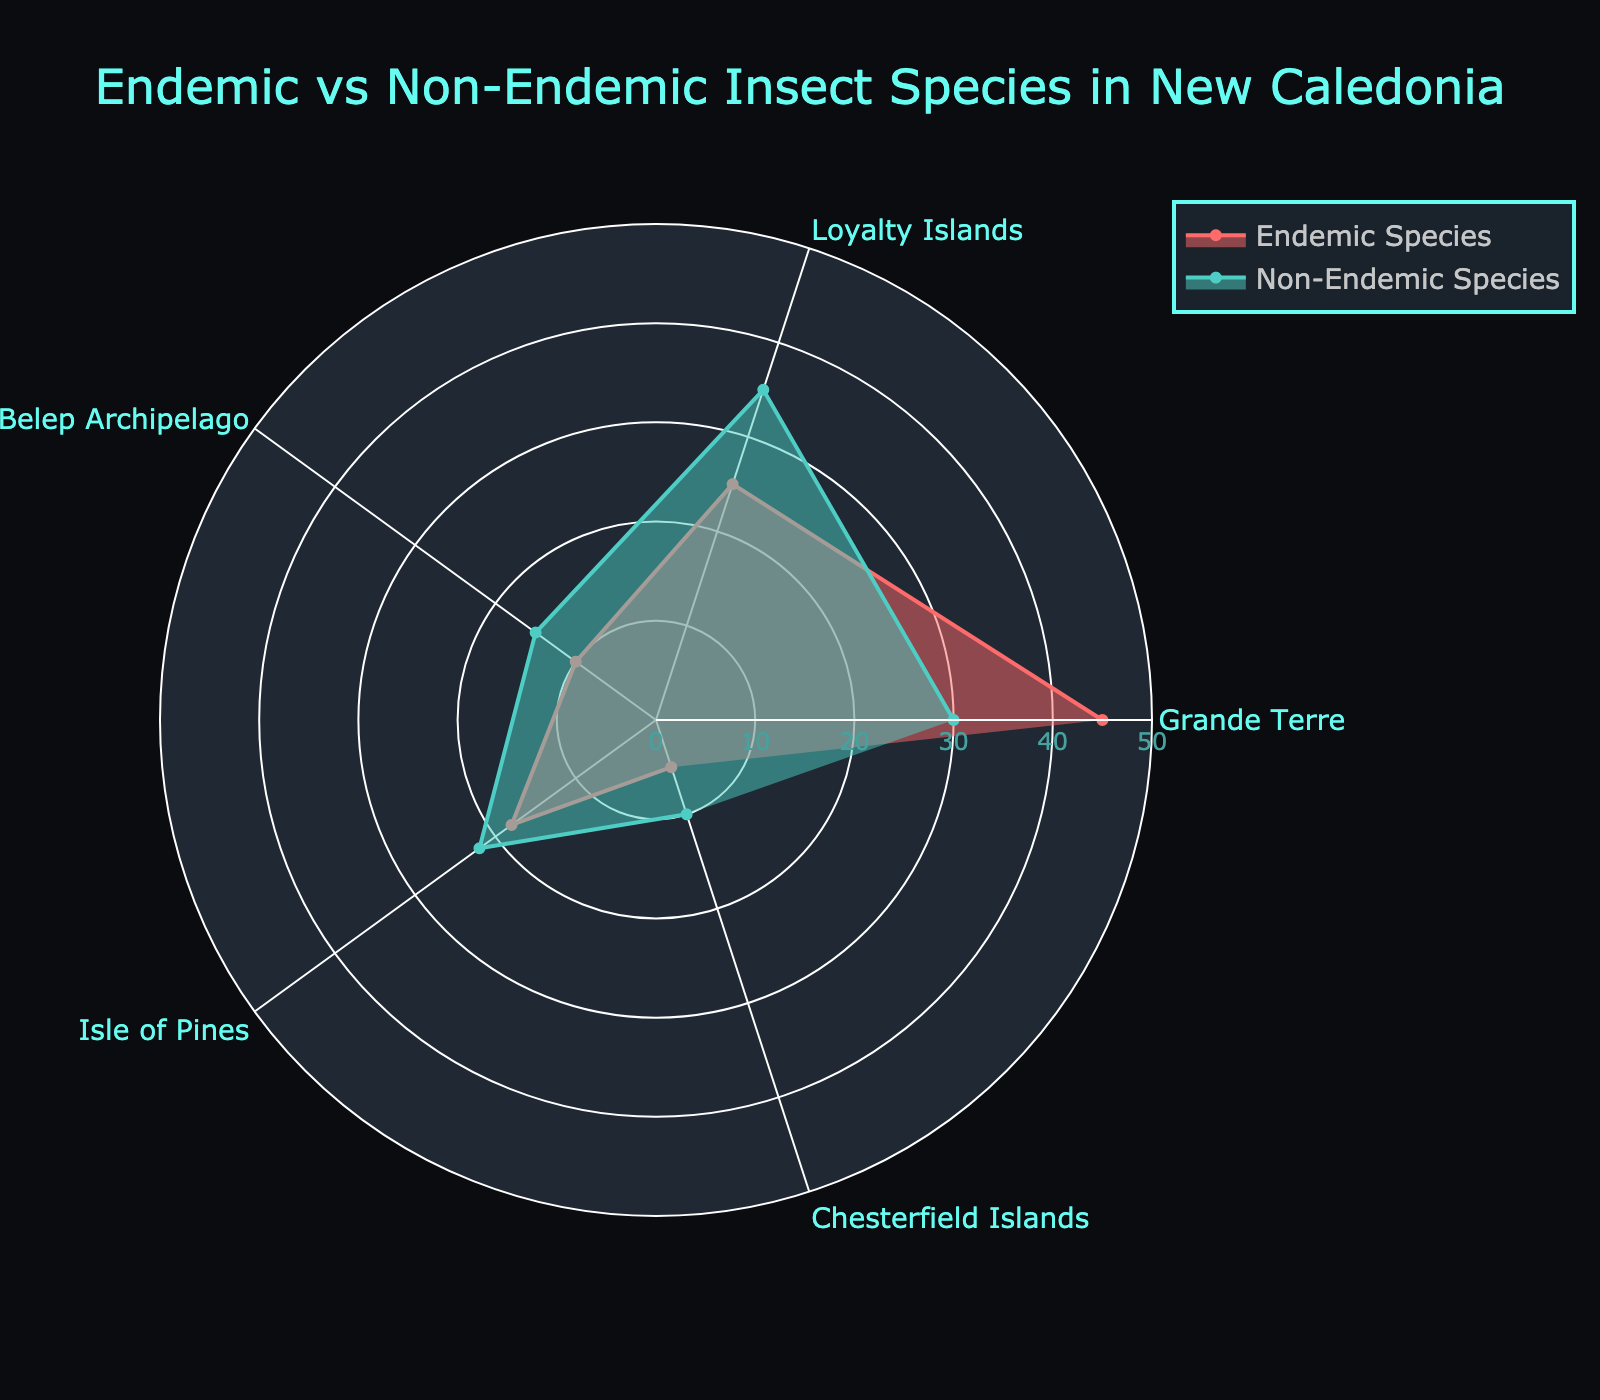What's the title of the radar chart? The title is typically displayed prominently at the top of the radar chart to give context about the data visualized.
Answer: Endemic vs Non-Endemic Insect Species in New Caledonia Which region has the highest number of endemic species? By visually inspecting the plot, we can see which region has the furthest point from the center for the endemic series.
Answer: Grande Terre In which region is the difference between endemic and non-endemic species smallest? We observe the radar chart and look for the regions where the points for endemic and non-endemic species are closest together.
Answer: Belep Archipelago What's the total number of endemic species across all regions? Sum of the endemic species across Grande Terre, Loyalty Islands, Belep Archipelago, Isle of Pines, and Chesterfield Islands: 45 + 25 + 10 + 18 + 5.
Answer: 103 How much larger is the number of endemic species compared to non-endemic species in Isle of Pines? Find the values for endemic and non-endemic species in Isle of Pines and calculate the difference: 18 (endemic) - 22 (non-endemic).
Answer: -4 Which region has more non-endemic species compared to endemic species? Compare each region and identify where the non-endemic series extends further from the center than the endemic series.
Answer: Loyalty Islands, Belep Archipelago, Isle of Pines, Chesterfield Islands What color represents the non-endemic species on the radar chart? The colors are mentioned in the legend and can be matched with the dataset they represent.
Answer: Teal What's the average number of non-endemic species across all regions? Sum all non-endemic species values and then divide by the number of regions: (30 + 35 + 15 + 22 + 10) / 5.
Answer: 22.4 Which region shows the greatest difference between endemic and non-endemic species? Identify the region with the maximum absolute difference between its endemic and non-endemic species values.
Answer: Loyalty Islands How does the number of non-endemic species in Chesterfield Islands compare to the number in Belep Archipelago? Direct comparison of the values: Chesterfield Islands has 10 non-endemic species, while Belep Archipelago has 15 non-endemic species.
Answer: Chesterfield Islands has fewer non-endemic species than Belep Archipelago 